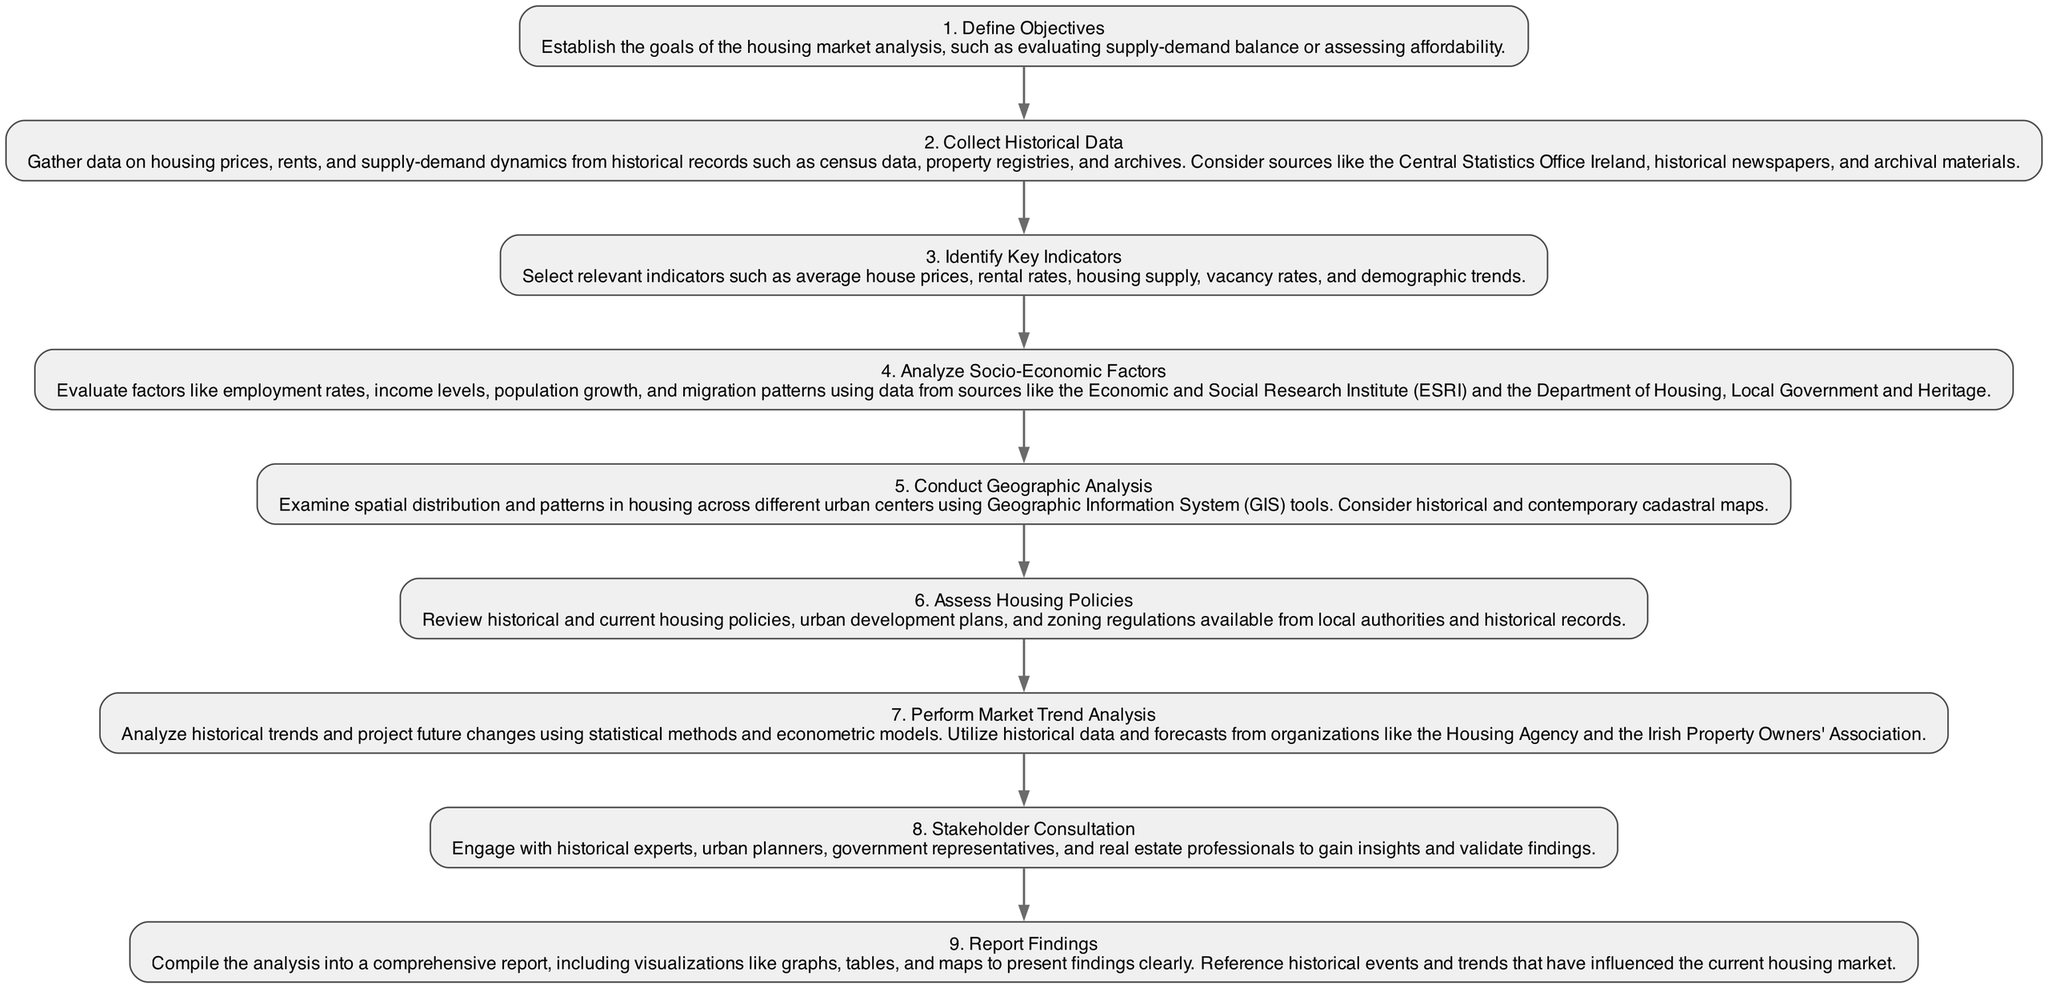What is the first step in the diagram? The first step in the diagram is labeled "Define Objectives." By examining the initial node in the flow chart, we can identify it clearly as the starting point of the analysis process.
Answer: Define Objectives How many steps are outlined in the diagram? By counting the individual steps represented as nodes in the diagram, we confirm there are nine distinct steps listed.
Answer: 9 What key indicators are chosen in the analysis? The step titled "Identify Key Indicators" specifies relevant indicators but does not list them directly; however, we infer it includes metrics like average house prices, and others relevant to housing market analysis. By recognizing this step's purpose, we remember the focus is on identifying crucial metrics.
Answer: Average house prices Which step directly follows "Assess Housing Policies"? The next step in the flow after "Assess Housing Policies" is "Perform Market Trend Analysis." By tracing the edges from this node, we ascertain the following process in the analysis.
Answer: Perform Market Trend Analysis What is the last step mentioned in the diagram? Observing the final node, we see that "Report Findings" is the concluding action of the analysis, which marks the completion of the steps taken in the housing market analysis.
Answer: Report Findings How does "Stakeholder Consultation" contribute to the analysis? "Stakeholder Consultation" engages various experts and professionals, validating findings through their insights. This step connects multiple perspectives to enhance accuracy in the analysis based on inputs gathered from varied stakeholders.
Answer: Validates findings What type of analysis is performed after analyzing socio-economic factors? The step immediately after "Analyze Socio-Economic Factors" is "Conduct Geographic Analysis." Following the process flow, we notice this shift occurs as part of comprehensive housing market assessment focusing on geographical data.
Answer: Conduct Geographic Analysis What is the significance of "Collect Historical Data" in the process? This step is foundational as it gathers essential historical information, which forms the basis for all other analyses. By understanding its role, we realize its vital importance in ensuring the analysis is backed by factual historical context.
Answer: Base for analysis Which organization might provide forecasts for market trend analysis? In the step titled "Perform Market Trend Analysis," it notes the use of forecasts from organizations like the Housing Agency. We can identify the connection between this step and the relevant forecasting body mentioned.
Answer: Housing Agency 